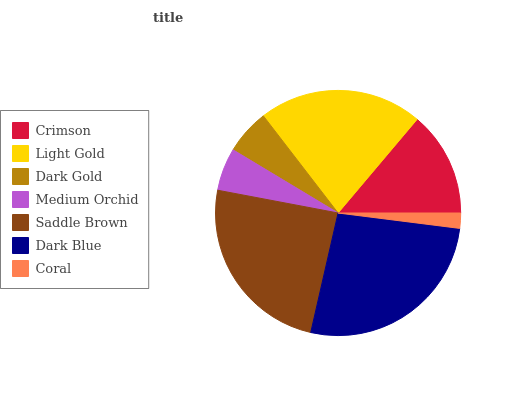Is Coral the minimum?
Answer yes or no. Yes. Is Dark Blue the maximum?
Answer yes or no. Yes. Is Light Gold the minimum?
Answer yes or no. No. Is Light Gold the maximum?
Answer yes or no. No. Is Light Gold greater than Crimson?
Answer yes or no. Yes. Is Crimson less than Light Gold?
Answer yes or no. Yes. Is Crimson greater than Light Gold?
Answer yes or no. No. Is Light Gold less than Crimson?
Answer yes or no. No. Is Crimson the high median?
Answer yes or no. Yes. Is Crimson the low median?
Answer yes or no. Yes. Is Medium Orchid the high median?
Answer yes or no. No. Is Light Gold the low median?
Answer yes or no. No. 